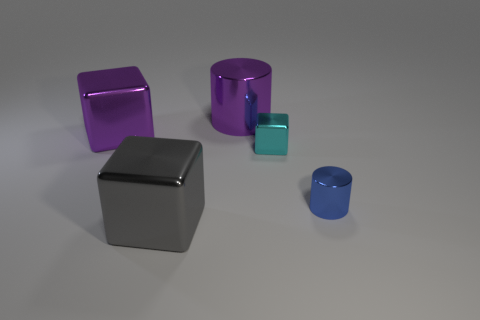Add 3 gray things. How many objects exist? 8 Subtract all cylinders. How many objects are left? 3 Subtract all big gray shiny things. Subtract all big purple objects. How many objects are left? 2 Add 3 large things. How many large things are left? 6 Add 3 small yellow shiny spheres. How many small yellow shiny spheres exist? 3 Subtract 0 gray cylinders. How many objects are left? 5 